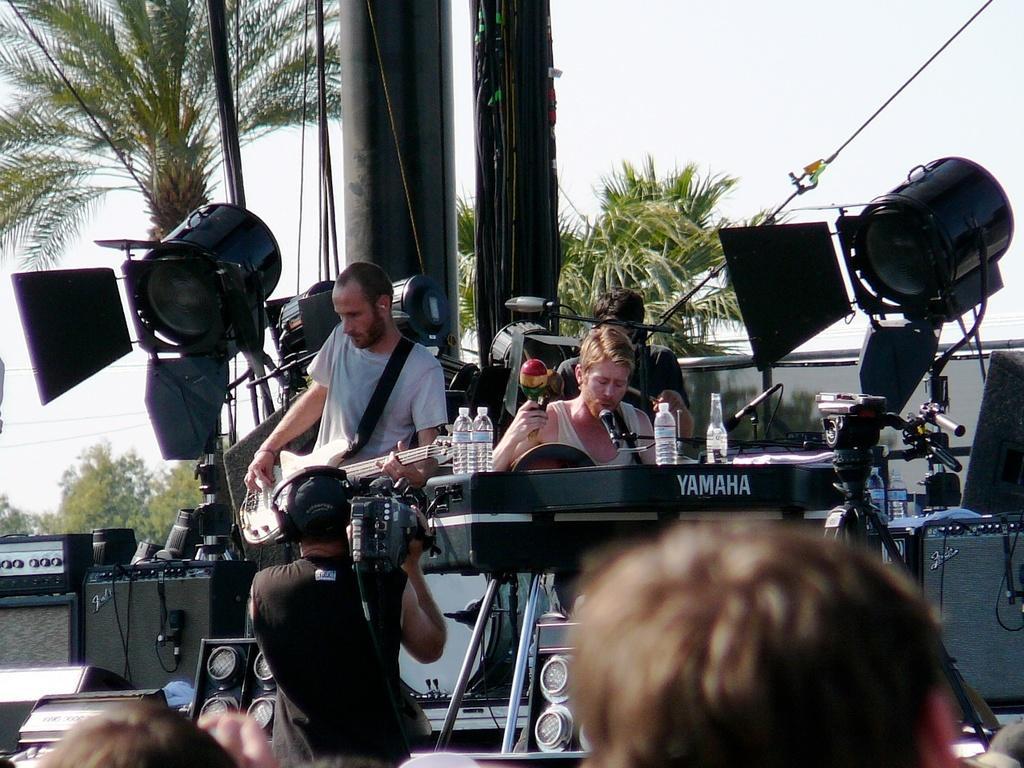Describe this image in one or two sentences. In this image there is a man standing and playing a guitar, next to him there is another man who is singing a song. There is a mic placed before him. There is a piano. There are bottles. In the center there is a man standing and holding a camera in his hand. In the background there are trees and pole. 